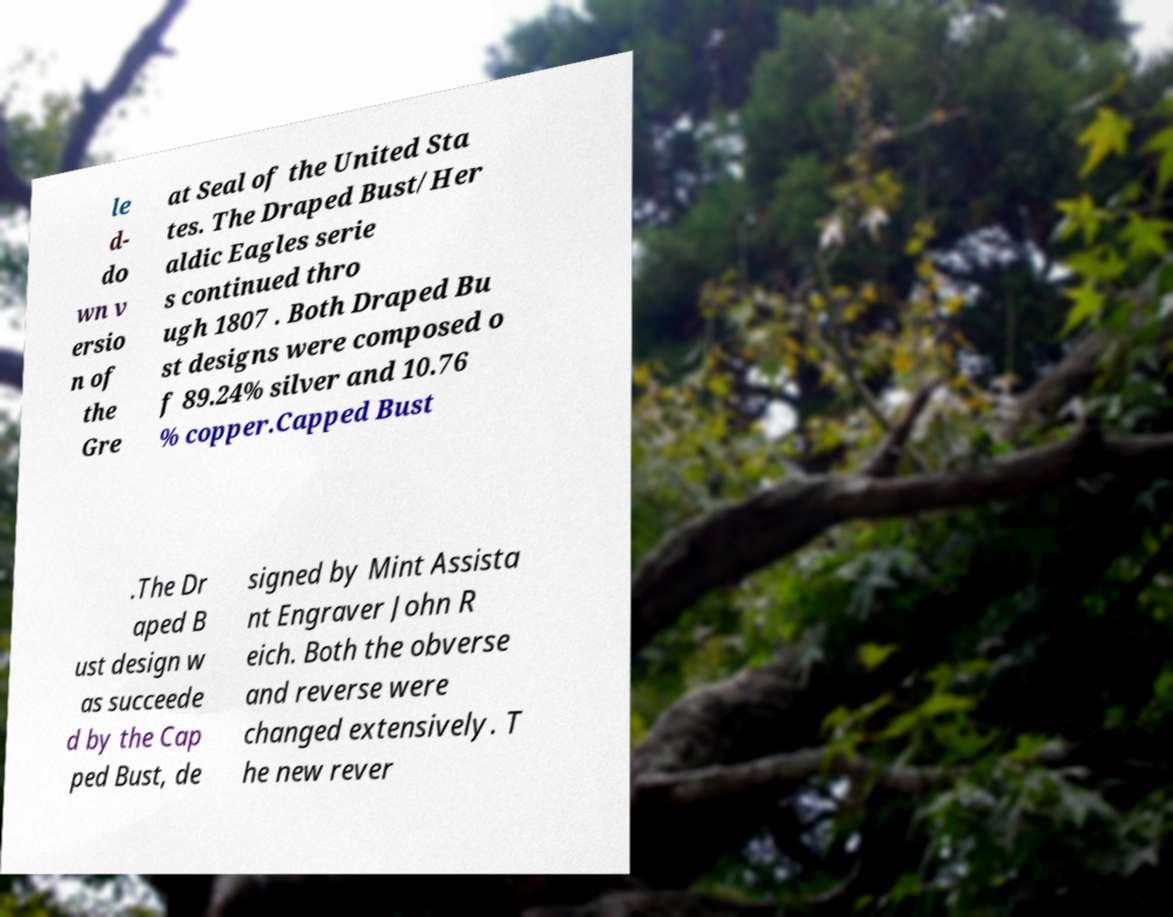Could you extract and type out the text from this image? le d- do wn v ersio n of the Gre at Seal of the United Sta tes. The Draped Bust/Her aldic Eagles serie s continued thro ugh 1807 . Both Draped Bu st designs were composed o f 89.24% silver and 10.76 % copper.Capped Bust .The Dr aped B ust design w as succeede d by the Cap ped Bust, de signed by Mint Assista nt Engraver John R eich. Both the obverse and reverse were changed extensively. T he new rever 